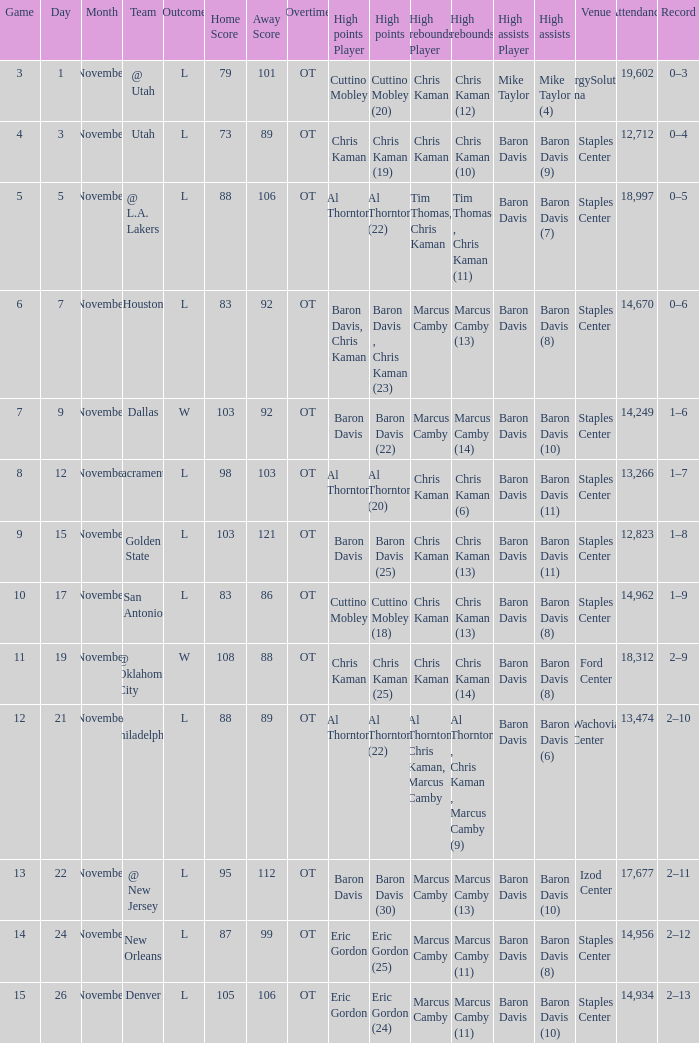Name the high assists for  l 98–103 (ot) Baron Davis (11). 